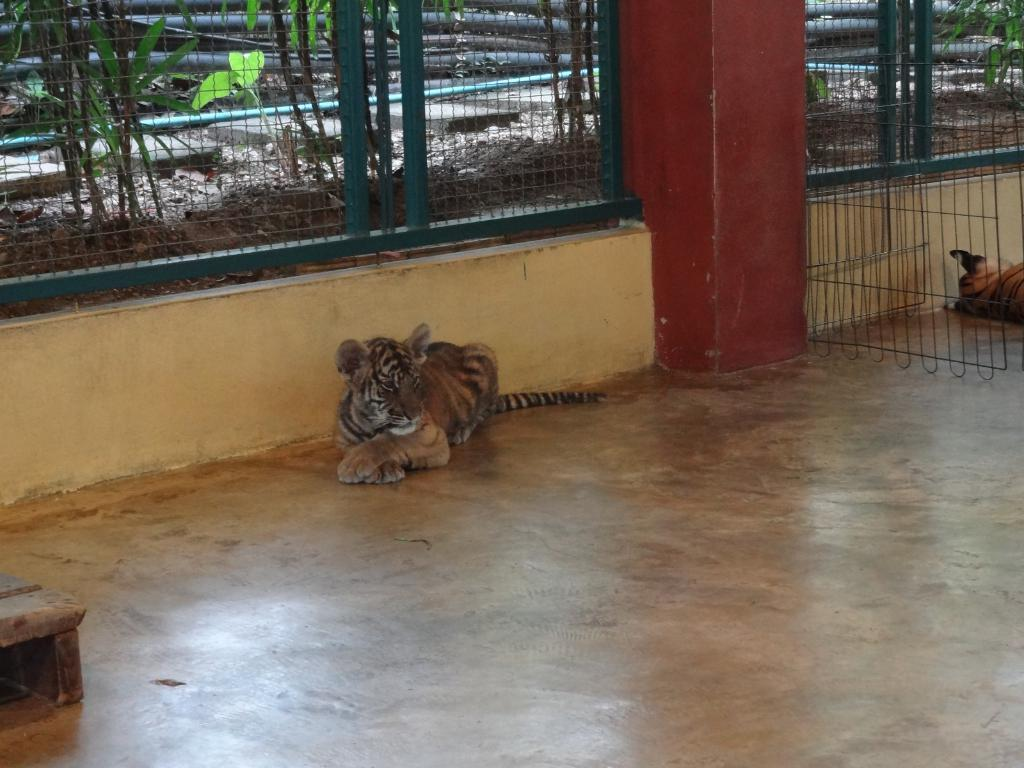What type of animals can be seen in the image? There are tigers in the image. What is the surface beneath the tigers? There is a floor in the image. What structures are present in the image? There are fences in the image. What can be seen through the fences? Leaves and objects are visible through the fences. What type of scent can be detected from the tigers in the image? There is no information about the scent of the tigers in the image, as it is a visual medium. 